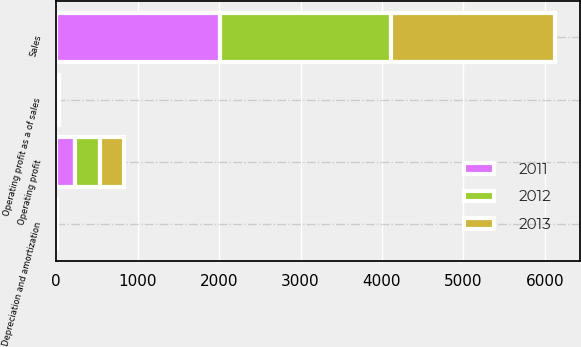Convert chart to OTSL. <chart><loc_0><loc_0><loc_500><loc_500><stacked_bar_chart><ecel><fcel>Sales<fcel>Operating profit<fcel>Depreciation and amortization<fcel>Operating profit as a of sales<nl><fcel>2012<fcel>2094.9<fcel>304.9<fcel>4<fcel>14.6<nl><fcel>2013<fcel>2022.9<fcel>293.1<fcel>4.6<fcel>14.5<nl><fcel>2011<fcel>2011.2<fcel>236.1<fcel>4.7<fcel>11.7<nl></chart> 